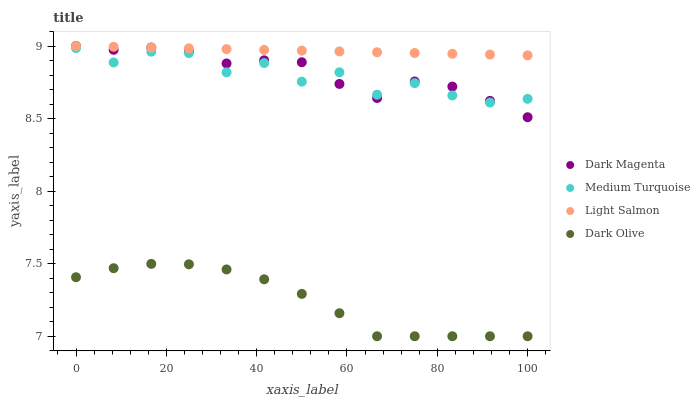Does Dark Olive have the minimum area under the curve?
Answer yes or no. Yes. Does Light Salmon have the maximum area under the curve?
Answer yes or no. Yes. Does Dark Magenta have the minimum area under the curve?
Answer yes or no. No. Does Dark Magenta have the maximum area under the curve?
Answer yes or no. No. Is Light Salmon the smoothest?
Answer yes or no. Yes. Is Medium Turquoise the roughest?
Answer yes or no. Yes. Is Dark Olive the smoothest?
Answer yes or no. No. Is Dark Olive the roughest?
Answer yes or no. No. Does Dark Olive have the lowest value?
Answer yes or no. Yes. Does Dark Magenta have the lowest value?
Answer yes or no. No. Does Dark Magenta have the highest value?
Answer yes or no. Yes. Does Dark Olive have the highest value?
Answer yes or no. No. Is Dark Olive less than Light Salmon?
Answer yes or no. Yes. Is Light Salmon greater than Dark Olive?
Answer yes or no. Yes. Does Dark Magenta intersect Medium Turquoise?
Answer yes or no. Yes. Is Dark Magenta less than Medium Turquoise?
Answer yes or no. No. Is Dark Magenta greater than Medium Turquoise?
Answer yes or no. No. Does Dark Olive intersect Light Salmon?
Answer yes or no. No. 